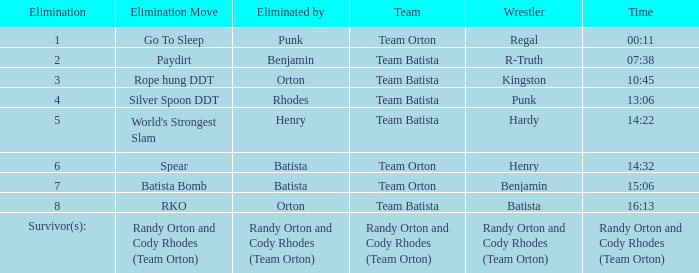Which Elimination move is listed against Team Orton, Eliminated by Batista against Elimination number 7? Batista Bomb. 